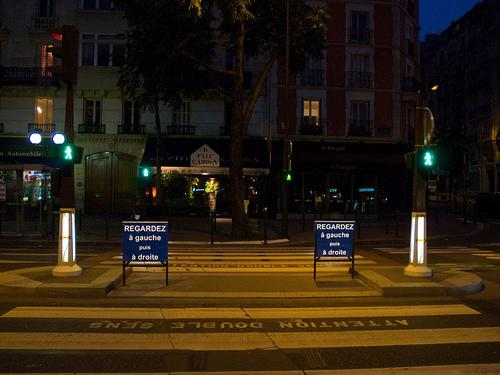What language is probably spoken in this locale? french 